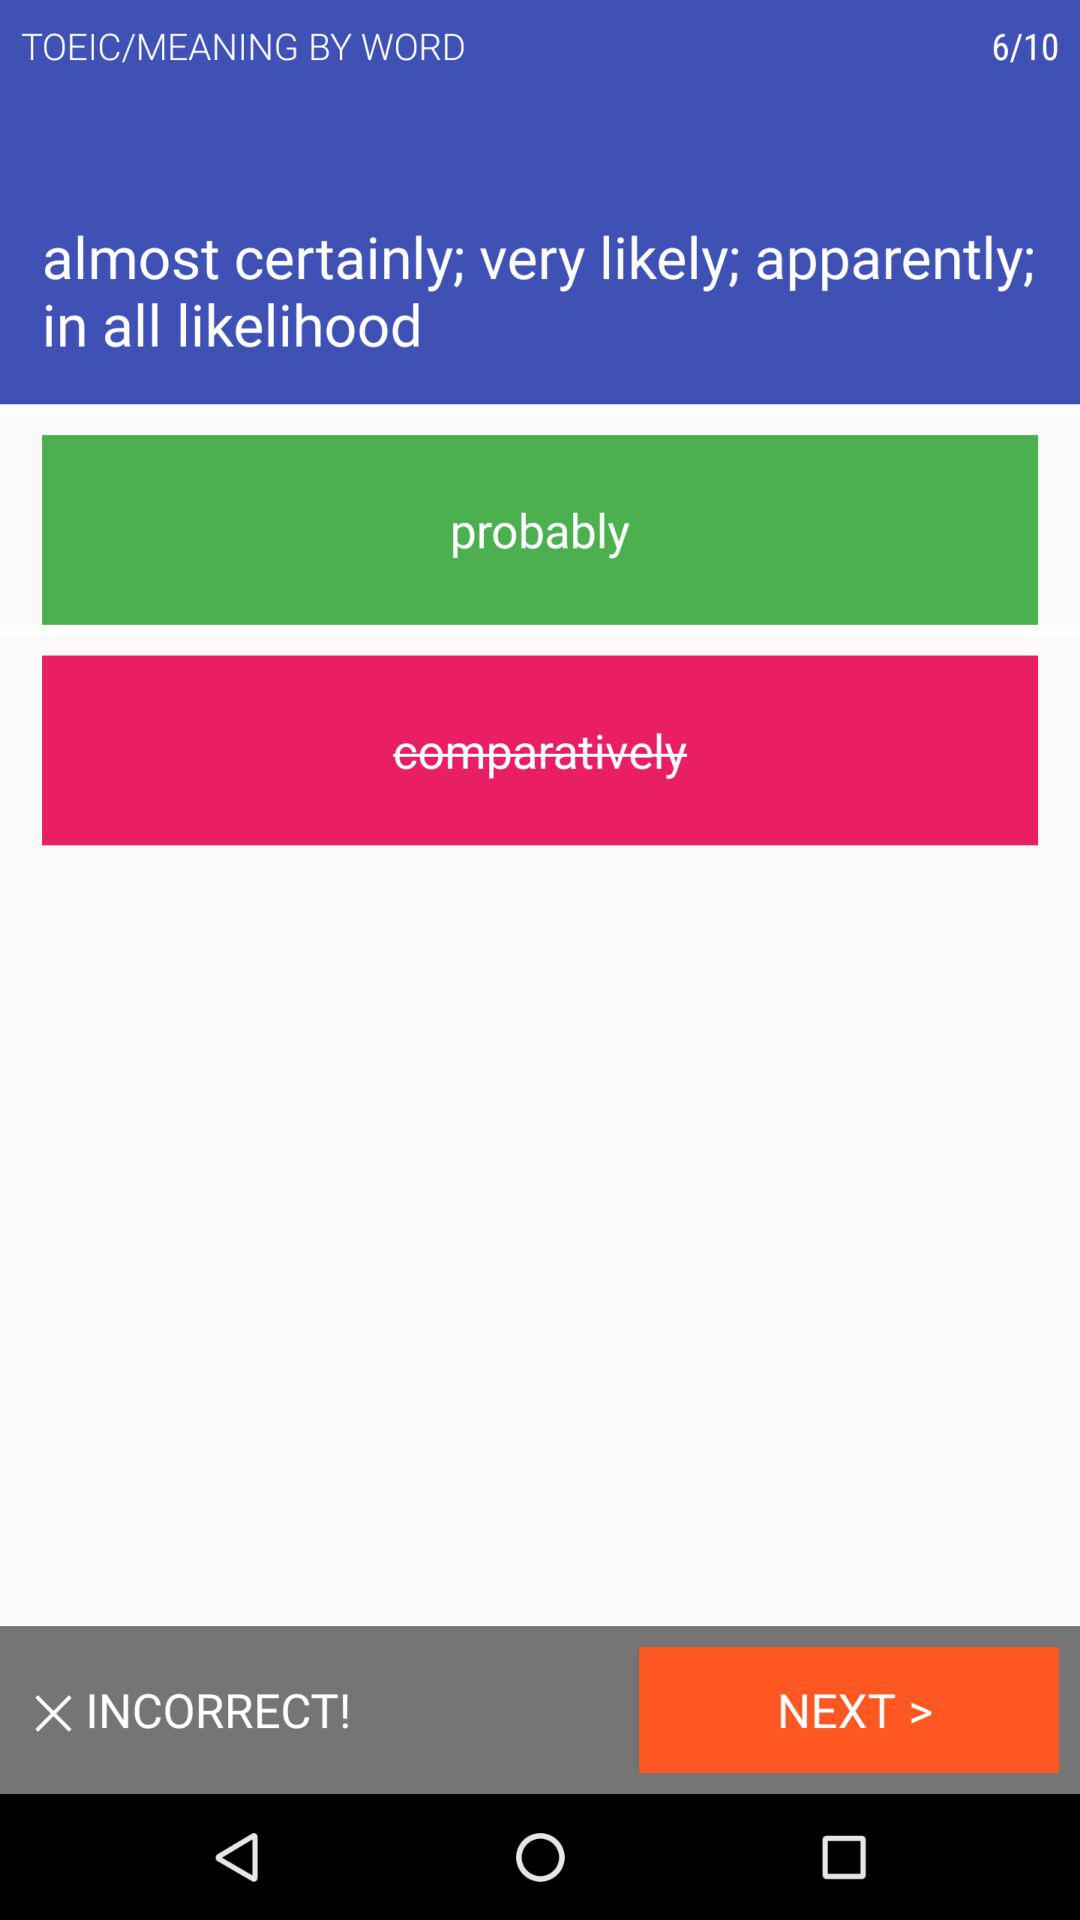What is the correct option for the question? The correct option for the question is "probably". 